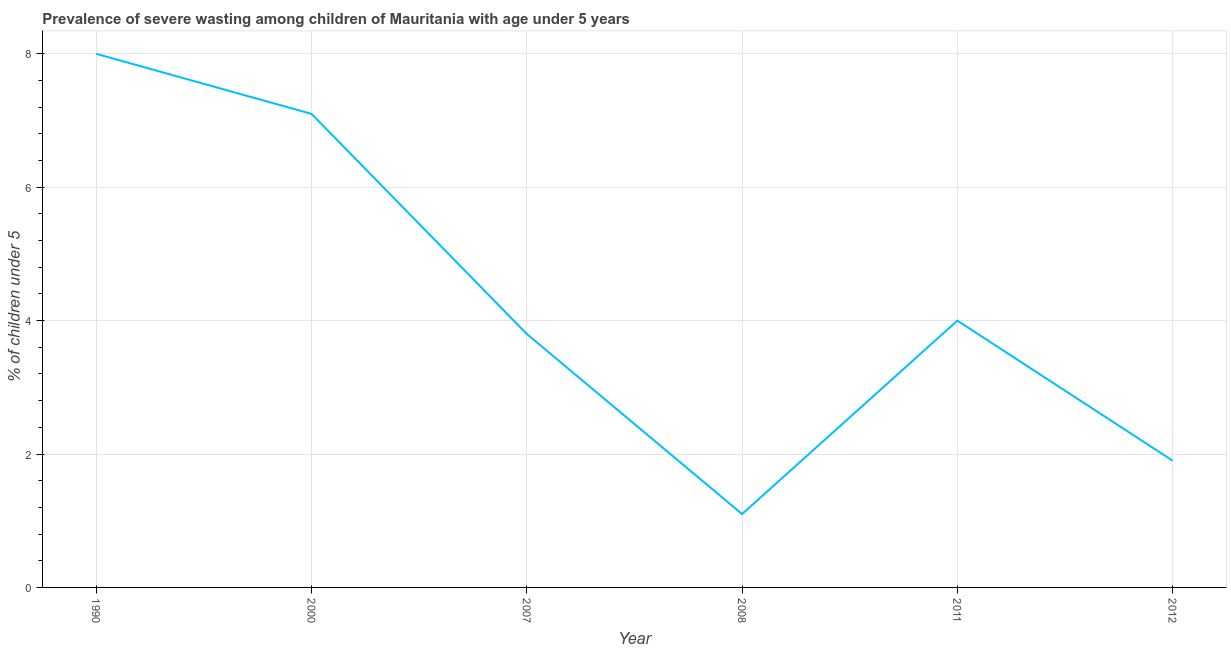What is the prevalence of severe wasting in 2012?
Keep it short and to the point. 1.9. Across all years, what is the maximum prevalence of severe wasting?
Give a very brief answer. 8. Across all years, what is the minimum prevalence of severe wasting?
Your answer should be compact. 1.1. In which year was the prevalence of severe wasting minimum?
Keep it short and to the point. 2008. What is the sum of the prevalence of severe wasting?
Make the answer very short. 25.9. What is the difference between the prevalence of severe wasting in 1990 and 2000?
Ensure brevity in your answer.  0.9. What is the average prevalence of severe wasting per year?
Offer a terse response. 4.32. What is the median prevalence of severe wasting?
Ensure brevity in your answer.  3.9. In how many years, is the prevalence of severe wasting greater than 6.4 %?
Provide a short and direct response. 2. What is the ratio of the prevalence of severe wasting in 1990 to that in 2011?
Your response must be concise. 2. Is the difference between the prevalence of severe wasting in 2000 and 2011 greater than the difference between any two years?
Offer a terse response. No. What is the difference between the highest and the second highest prevalence of severe wasting?
Give a very brief answer. 0.9. Is the sum of the prevalence of severe wasting in 2007 and 2008 greater than the maximum prevalence of severe wasting across all years?
Offer a terse response. No. What is the difference between the highest and the lowest prevalence of severe wasting?
Your answer should be compact. 6.9. In how many years, is the prevalence of severe wasting greater than the average prevalence of severe wasting taken over all years?
Provide a succinct answer. 2. Does the prevalence of severe wasting monotonically increase over the years?
Keep it short and to the point. No. How many lines are there?
Your answer should be compact. 1. What is the difference between two consecutive major ticks on the Y-axis?
Your response must be concise. 2. Does the graph contain grids?
Offer a terse response. Yes. What is the title of the graph?
Give a very brief answer. Prevalence of severe wasting among children of Mauritania with age under 5 years. What is the label or title of the Y-axis?
Your answer should be compact.  % of children under 5. What is the  % of children under 5 in 2000?
Provide a short and direct response. 7.1. What is the  % of children under 5 of 2007?
Provide a succinct answer. 3.8. What is the  % of children under 5 of 2008?
Provide a succinct answer. 1.1. What is the  % of children under 5 in 2012?
Offer a terse response. 1.9. What is the difference between the  % of children under 5 in 1990 and 2007?
Offer a very short reply. 4.2. What is the difference between the  % of children under 5 in 1990 and 2008?
Your answer should be compact. 6.9. What is the difference between the  % of children under 5 in 1990 and 2011?
Offer a very short reply. 4. What is the difference between the  % of children under 5 in 1990 and 2012?
Provide a short and direct response. 6.1. What is the difference between the  % of children under 5 in 2000 and 2011?
Provide a succinct answer. 3.1. What is the difference between the  % of children under 5 in 2000 and 2012?
Offer a terse response. 5.2. What is the difference between the  % of children under 5 in 2007 and 2011?
Offer a terse response. -0.2. What is the difference between the  % of children under 5 in 2008 and 2011?
Keep it short and to the point. -2.9. What is the ratio of the  % of children under 5 in 1990 to that in 2000?
Offer a very short reply. 1.13. What is the ratio of the  % of children under 5 in 1990 to that in 2007?
Your answer should be very brief. 2.1. What is the ratio of the  % of children under 5 in 1990 to that in 2008?
Offer a terse response. 7.27. What is the ratio of the  % of children under 5 in 1990 to that in 2011?
Provide a short and direct response. 2. What is the ratio of the  % of children under 5 in 1990 to that in 2012?
Give a very brief answer. 4.21. What is the ratio of the  % of children under 5 in 2000 to that in 2007?
Provide a short and direct response. 1.87. What is the ratio of the  % of children under 5 in 2000 to that in 2008?
Give a very brief answer. 6.46. What is the ratio of the  % of children under 5 in 2000 to that in 2011?
Offer a very short reply. 1.77. What is the ratio of the  % of children under 5 in 2000 to that in 2012?
Ensure brevity in your answer.  3.74. What is the ratio of the  % of children under 5 in 2007 to that in 2008?
Offer a terse response. 3.46. What is the ratio of the  % of children under 5 in 2008 to that in 2011?
Your answer should be compact. 0.28. What is the ratio of the  % of children under 5 in 2008 to that in 2012?
Give a very brief answer. 0.58. What is the ratio of the  % of children under 5 in 2011 to that in 2012?
Your response must be concise. 2.1. 